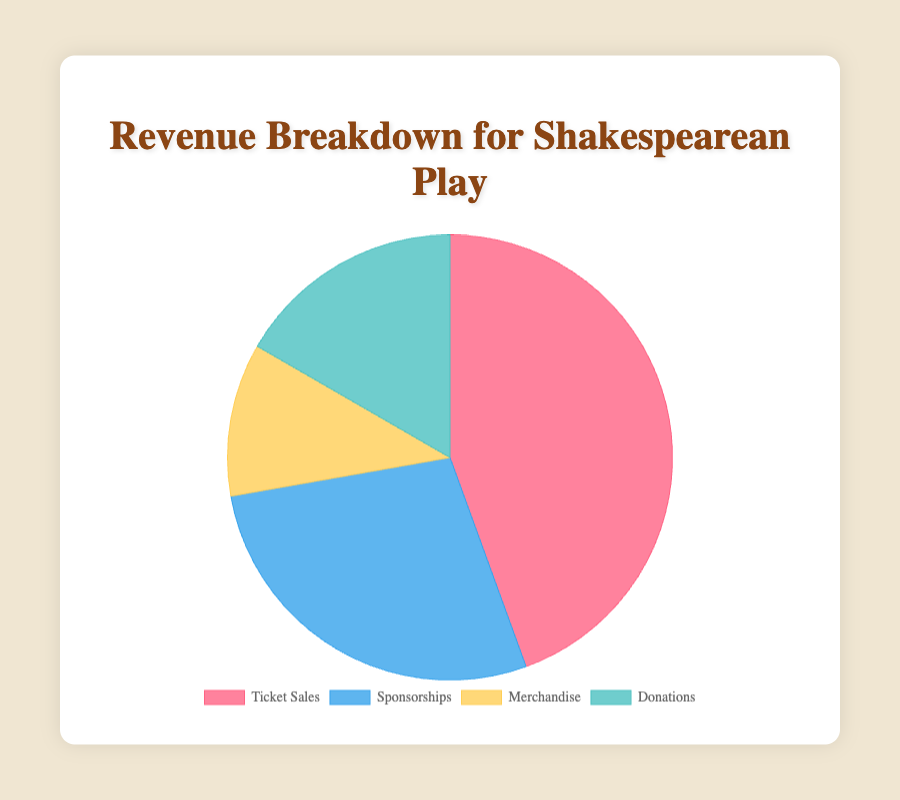What's the largest revenue source for the Shakespearean play? The largest segment of the pie chart represents the highest revenue source. Ticket Sales cover the largest portion.
Answer: Ticket Sales What is the total revenue generated from both Ticket Sales and Merchandise? Sum the amounts from Ticket Sales and Merchandise: $40,000 + $10,000 = $50,000
Answer: $50,000 How does the revenue from Donations compare to Sponsorships? The Donations segment is smaller than Sponsorships. Amounts: $15,000 (Donations) vs $25,000 (Sponsorships).
Answer: Donations are less than Sponsorships What's the proportion of revenue from Ticket Sales relative to the total revenue? Total revenue is the sum of all amounts: $40,000 + $25,000 + $10,000 + $15,000 = $90,000. Proportion from Ticket Sales = $40,000 / $90,000 = 44.44%
Answer: 44.44% If the revenue from Sponsorships were to increase by 20%, what would the new amount be? 20% of $25,000 is calculated as $25,000 * 0.20 = $5,000. New Sponsorships amount = $25,000 + $5,000 = $30,000
Answer: $30,000 Which two revenue sources combined make up half of the total revenue? The total revenue is $90,000. Half of this is $45,000. Combining Ticket Sales ($40,000) and Donations ($15,000) gives $55,000, which is above half. Instead, Ticket Sales ($40,000) and Sponsorships ($25,000) together make $65,000, which is more than half too. Combining Ticket Sales with either Sponsorships or Donations will exceed half.
Answer: Not possible What percentage of total revenue is generated from Merchandise? Merchandise revenue is $10,000; total revenue is $90,000. Percentage = ($10,000 / $90,000) * 100 = 11.11%
Answer: 11.11% Which has a greater revenue: the sum of Sponsorships and Merchandise or the sum of Ticket Sales and Donations? Sum of Sponsorships and Merchandise: $25,000 + $10,000 = $35,000. Sum of Ticket Sales and Donations: $40,000 + $15,000 = $55,000.
Answer: Ticket Sales and Donations Does the sum of Merchandise and Donations exceed the amount from Ticket Sales? Sum of Merchandise and Donations: $10,000 + $15,000 = $25,000. Ticket Sales: $40,000.
Answer: No 